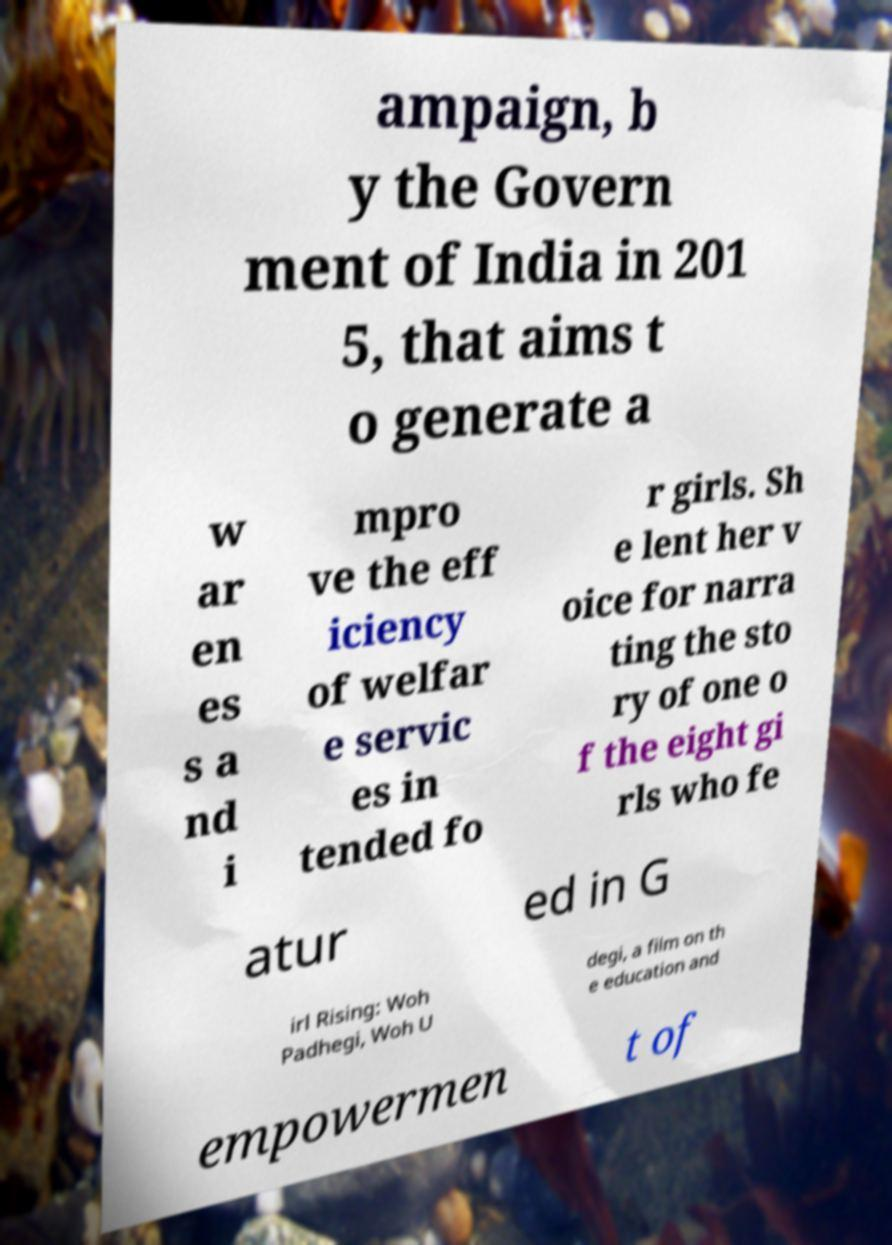Can you accurately transcribe the text from the provided image for me? ampaign, b y the Govern ment of India in 201 5, that aims t o generate a w ar en es s a nd i mpro ve the eff iciency of welfar e servic es in tended fo r girls. Sh e lent her v oice for narra ting the sto ry of one o f the eight gi rls who fe atur ed in G irl Rising: Woh Padhegi, Woh U degi, a film on th e education and empowermen t of 